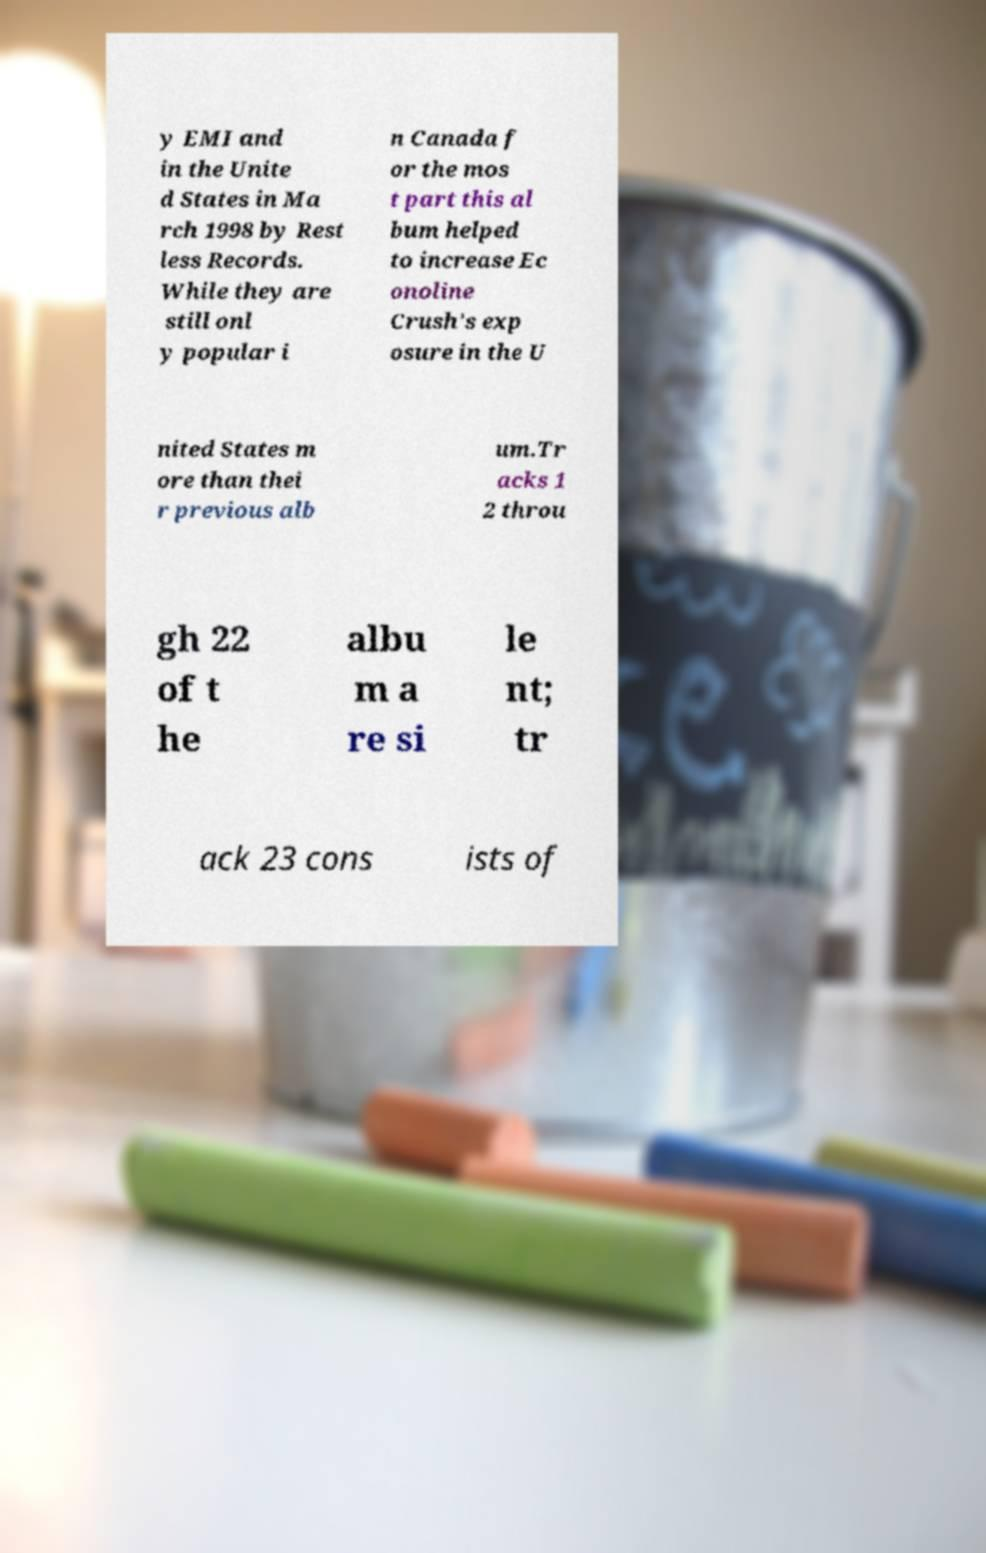What messages or text are displayed in this image? I need them in a readable, typed format. y EMI and in the Unite d States in Ma rch 1998 by Rest less Records. While they are still onl y popular i n Canada f or the mos t part this al bum helped to increase Ec onoline Crush's exp osure in the U nited States m ore than thei r previous alb um.Tr acks 1 2 throu gh 22 of t he albu m a re si le nt; tr ack 23 cons ists of 